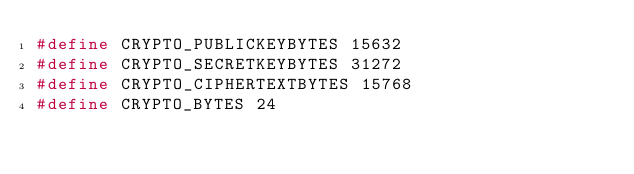<code> <loc_0><loc_0><loc_500><loc_500><_C_>#define CRYPTO_PUBLICKEYBYTES 15632
#define CRYPTO_SECRETKEYBYTES 31272
#define CRYPTO_CIPHERTEXTBYTES 15768
#define CRYPTO_BYTES 24
</code> 